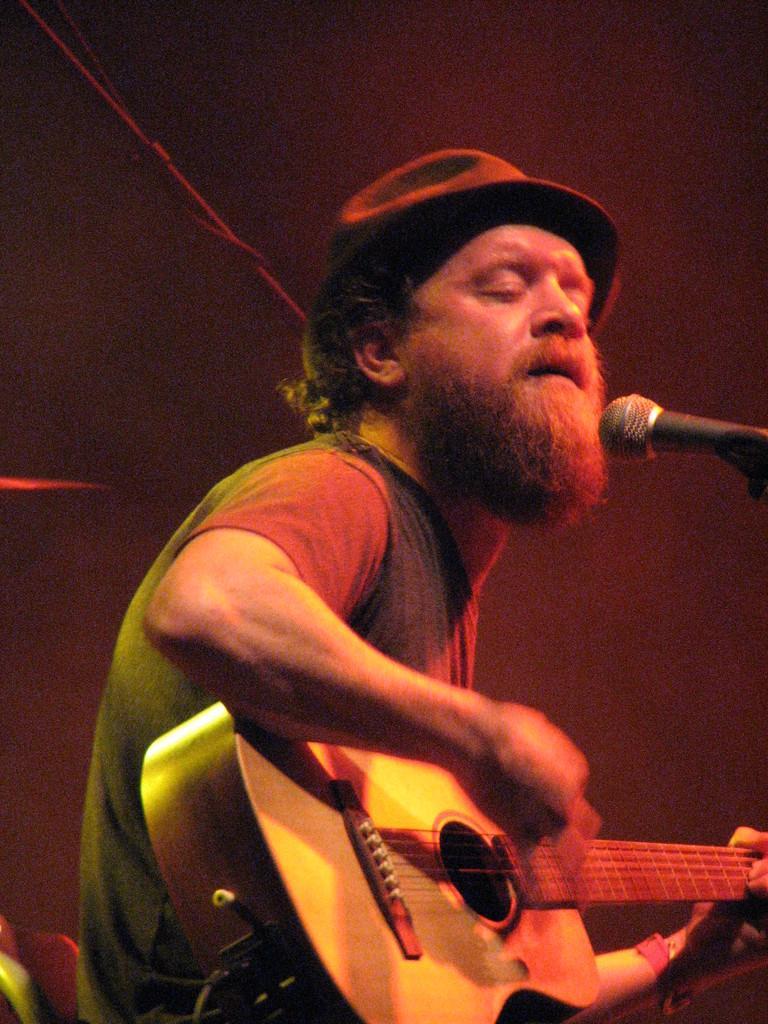Please provide a concise description of this image. In the picture a man is holding the guitar and playing the guitar and singing a song there is a mike in front of him he is wearing a hat, black color hat. 